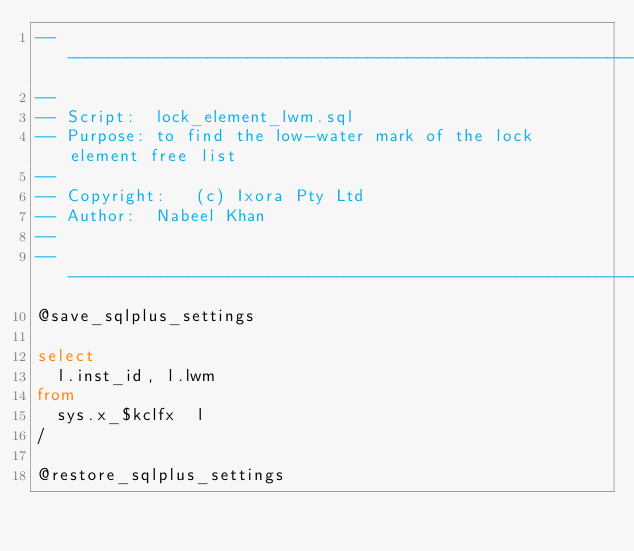<code> <loc_0><loc_0><loc_500><loc_500><_SQL_>-------------------------------------------------------------------------------
--
-- Script:	lock_element_lwm.sql
-- Purpose:	to find the low-water mark of the lock element free list
--
-- Copyright:	(c) Ixora Pty Ltd
-- Author:	Nabeel Khan
--
-------------------------------------------------------------------------------
@save_sqlplus_settings

select
  l.inst_id, l.lwm
from
  sys.x_$kclfx  l
/

@restore_sqlplus_settings
</code> 